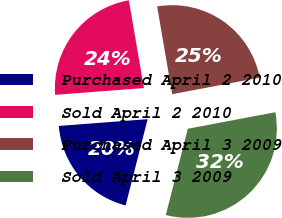Convert chart to OTSL. <chart><loc_0><loc_0><loc_500><loc_500><pie_chart><fcel>Purchased April 2 2010<fcel>Sold April 2 2010<fcel>Purchased April 3 2009<fcel>Sold April 3 2009<nl><fcel>19.81%<fcel>23.51%<fcel>24.73%<fcel>31.95%<nl></chart> 